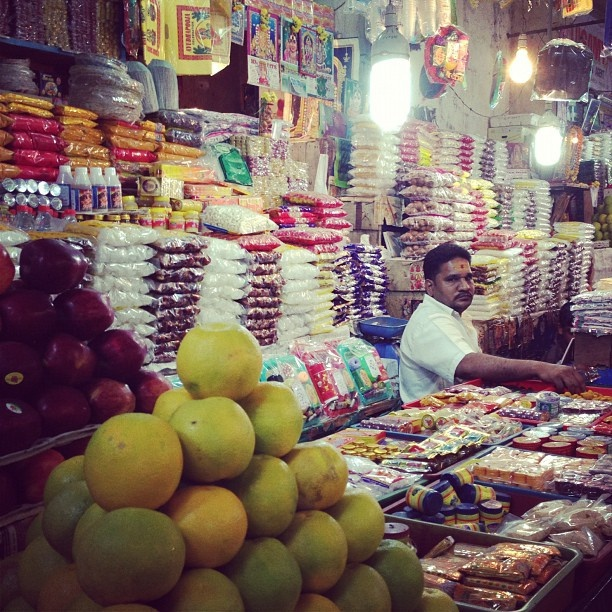Describe the objects in this image and their specific colors. I can see people in purple, beige, and darkgray tones, orange in purple, black, darkgreen, and gray tones, orange in purple, olive, and maroon tones, orange in purple, khaki, and olive tones, and orange in purple, olive, and maroon tones in this image. 